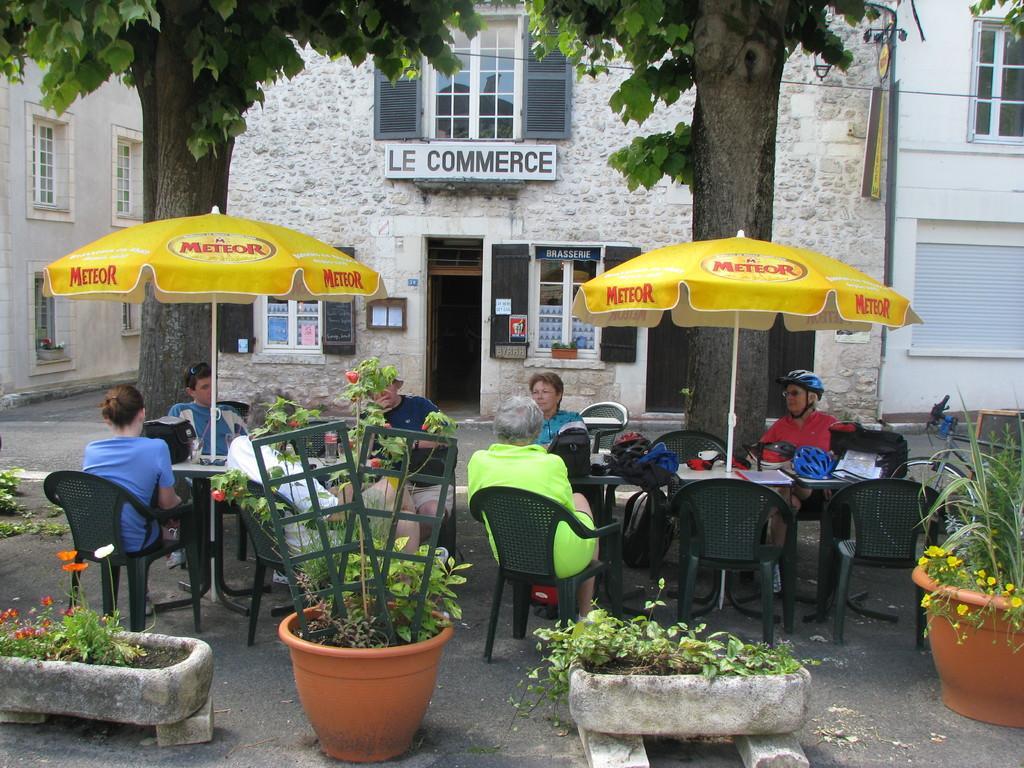Describe this image in one or two sentences. In the image we can see there are lot of people who are sitting on chair and in front of them there is a table on which there is a helmet and at the back there is a building. 